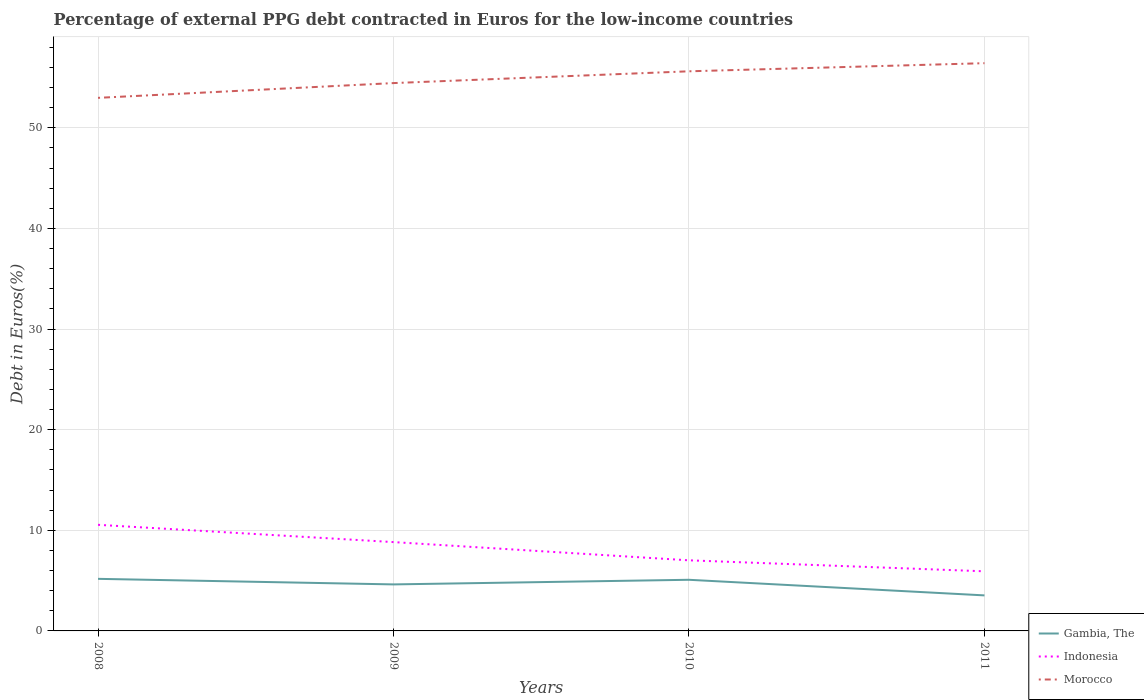How many different coloured lines are there?
Provide a succinct answer. 3. Does the line corresponding to Morocco intersect with the line corresponding to Indonesia?
Offer a very short reply. No. Across all years, what is the maximum percentage of external PPG debt contracted in Euros in Morocco?
Your response must be concise. 52.98. What is the total percentage of external PPG debt contracted in Euros in Gambia, The in the graph?
Your response must be concise. 1.55. What is the difference between the highest and the second highest percentage of external PPG debt contracted in Euros in Morocco?
Offer a very short reply. 3.45. What is the difference between the highest and the lowest percentage of external PPG debt contracted in Euros in Gambia, The?
Offer a terse response. 3. Is the percentage of external PPG debt contracted in Euros in Indonesia strictly greater than the percentage of external PPG debt contracted in Euros in Morocco over the years?
Ensure brevity in your answer.  Yes. How many lines are there?
Ensure brevity in your answer.  3. How many years are there in the graph?
Offer a terse response. 4. What is the difference between two consecutive major ticks on the Y-axis?
Make the answer very short. 10. Does the graph contain any zero values?
Make the answer very short. No. Does the graph contain grids?
Make the answer very short. Yes. Where does the legend appear in the graph?
Ensure brevity in your answer.  Bottom right. What is the title of the graph?
Provide a short and direct response. Percentage of external PPG debt contracted in Euros for the low-income countries. Does "Congo (Democratic)" appear as one of the legend labels in the graph?
Your answer should be very brief. No. What is the label or title of the Y-axis?
Your response must be concise. Debt in Euros(%). What is the Debt in Euros(%) in Gambia, The in 2008?
Offer a terse response. 5.18. What is the Debt in Euros(%) of Indonesia in 2008?
Offer a terse response. 10.55. What is the Debt in Euros(%) of Morocco in 2008?
Your answer should be compact. 52.98. What is the Debt in Euros(%) of Gambia, The in 2009?
Provide a succinct answer. 4.62. What is the Debt in Euros(%) of Indonesia in 2009?
Keep it short and to the point. 8.83. What is the Debt in Euros(%) in Morocco in 2009?
Give a very brief answer. 54.45. What is the Debt in Euros(%) in Gambia, The in 2010?
Offer a terse response. 5.08. What is the Debt in Euros(%) of Indonesia in 2010?
Make the answer very short. 7.02. What is the Debt in Euros(%) in Morocco in 2010?
Your response must be concise. 55.62. What is the Debt in Euros(%) of Gambia, The in 2011?
Your response must be concise. 3.53. What is the Debt in Euros(%) of Indonesia in 2011?
Your answer should be very brief. 5.92. What is the Debt in Euros(%) of Morocco in 2011?
Your response must be concise. 56.43. Across all years, what is the maximum Debt in Euros(%) of Gambia, The?
Offer a very short reply. 5.18. Across all years, what is the maximum Debt in Euros(%) in Indonesia?
Offer a very short reply. 10.55. Across all years, what is the maximum Debt in Euros(%) of Morocco?
Your answer should be very brief. 56.43. Across all years, what is the minimum Debt in Euros(%) of Gambia, The?
Your response must be concise. 3.53. Across all years, what is the minimum Debt in Euros(%) in Indonesia?
Provide a succinct answer. 5.92. Across all years, what is the minimum Debt in Euros(%) in Morocco?
Your response must be concise. 52.98. What is the total Debt in Euros(%) of Gambia, The in the graph?
Make the answer very short. 18.41. What is the total Debt in Euros(%) in Indonesia in the graph?
Your answer should be compact. 32.32. What is the total Debt in Euros(%) of Morocco in the graph?
Offer a very short reply. 219.49. What is the difference between the Debt in Euros(%) in Gambia, The in 2008 and that in 2009?
Give a very brief answer. 0.55. What is the difference between the Debt in Euros(%) in Indonesia in 2008 and that in 2009?
Your answer should be very brief. 1.72. What is the difference between the Debt in Euros(%) of Morocco in 2008 and that in 2009?
Provide a succinct answer. -1.47. What is the difference between the Debt in Euros(%) in Gambia, The in 2008 and that in 2010?
Keep it short and to the point. 0.09. What is the difference between the Debt in Euros(%) in Indonesia in 2008 and that in 2010?
Make the answer very short. 3.53. What is the difference between the Debt in Euros(%) of Morocco in 2008 and that in 2010?
Provide a succinct answer. -2.64. What is the difference between the Debt in Euros(%) of Gambia, The in 2008 and that in 2011?
Offer a terse response. 1.64. What is the difference between the Debt in Euros(%) of Indonesia in 2008 and that in 2011?
Ensure brevity in your answer.  4.62. What is the difference between the Debt in Euros(%) of Morocco in 2008 and that in 2011?
Your response must be concise. -3.45. What is the difference between the Debt in Euros(%) in Gambia, The in 2009 and that in 2010?
Give a very brief answer. -0.46. What is the difference between the Debt in Euros(%) of Indonesia in 2009 and that in 2010?
Offer a terse response. 1.81. What is the difference between the Debt in Euros(%) of Morocco in 2009 and that in 2010?
Your response must be concise. -1.17. What is the difference between the Debt in Euros(%) in Gambia, The in 2009 and that in 2011?
Your answer should be very brief. 1.09. What is the difference between the Debt in Euros(%) in Indonesia in 2009 and that in 2011?
Provide a short and direct response. 2.9. What is the difference between the Debt in Euros(%) in Morocco in 2009 and that in 2011?
Keep it short and to the point. -1.98. What is the difference between the Debt in Euros(%) of Gambia, The in 2010 and that in 2011?
Offer a terse response. 1.55. What is the difference between the Debt in Euros(%) of Indonesia in 2010 and that in 2011?
Your response must be concise. 1.09. What is the difference between the Debt in Euros(%) of Morocco in 2010 and that in 2011?
Ensure brevity in your answer.  -0.81. What is the difference between the Debt in Euros(%) in Gambia, The in 2008 and the Debt in Euros(%) in Indonesia in 2009?
Provide a short and direct response. -3.65. What is the difference between the Debt in Euros(%) in Gambia, The in 2008 and the Debt in Euros(%) in Morocco in 2009?
Keep it short and to the point. -49.28. What is the difference between the Debt in Euros(%) in Indonesia in 2008 and the Debt in Euros(%) in Morocco in 2009?
Provide a succinct answer. -43.91. What is the difference between the Debt in Euros(%) in Gambia, The in 2008 and the Debt in Euros(%) in Indonesia in 2010?
Your answer should be compact. -1.84. What is the difference between the Debt in Euros(%) in Gambia, The in 2008 and the Debt in Euros(%) in Morocco in 2010?
Your answer should be compact. -50.45. What is the difference between the Debt in Euros(%) in Indonesia in 2008 and the Debt in Euros(%) in Morocco in 2010?
Offer a very short reply. -45.08. What is the difference between the Debt in Euros(%) in Gambia, The in 2008 and the Debt in Euros(%) in Indonesia in 2011?
Make the answer very short. -0.75. What is the difference between the Debt in Euros(%) in Gambia, The in 2008 and the Debt in Euros(%) in Morocco in 2011?
Your answer should be very brief. -51.25. What is the difference between the Debt in Euros(%) in Indonesia in 2008 and the Debt in Euros(%) in Morocco in 2011?
Your answer should be compact. -45.88. What is the difference between the Debt in Euros(%) in Gambia, The in 2009 and the Debt in Euros(%) in Indonesia in 2010?
Provide a succinct answer. -2.39. What is the difference between the Debt in Euros(%) in Gambia, The in 2009 and the Debt in Euros(%) in Morocco in 2010?
Offer a terse response. -51. What is the difference between the Debt in Euros(%) of Indonesia in 2009 and the Debt in Euros(%) of Morocco in 2010?
Give a very brief answer. -46.79. What is the difference between the Debt in Euros(%) of Gambia, The in 2009 and the Debt in Euros(%) of Indonesia in 2011?
Give a very brief answer. -1.3. What is the difference between the Debt in Euros(%) of Gambia, The in 2009 and the Debt in Euros(%) of Morocco in 2011?
Provide a succinct answer. -51.81. What is the difference between the Debt in Euros(%) of Indonesia in 2009 and the Debt in Euros(%) of Morocco in 2011?
Offer a very short reply. -47.6. What is the difference between the Debt in Euros(%) of Gambia, The in 2010 and the Debt in Euros(%) of Indonesia in 2011?
Keep it short and to the point. -0.84. What is the difference between the Debt in Euros(%) in Gambia, The in 2010 and the Debt in Euros(%) in Morocco in 2011?
Provide a succinct answer. -51.35. What is the difference between the Debt in Euros(%) in Indonesia in 2010 and the Debt in Euros(%) in Morocco in 2011?
Provide a succinct answer. -49.41. What is the average Debt in Euros(%) of Gambia, The per year?
Your response must be concise. 4.6. What is the average Debt in Euros(%) of Indonesia per year?
Offer a very short reply. 8.08. What is the average Debt in Euros(%) of Morocco per year?
Your answer should be compact. 54.87. In the year 2008, what is the difference between the Debt in Euros(%) in Gambia, The and Debt in Euros(%) in Indonesia?
Give a very brief answer. -5.37. In the year 2008, what is the difference between the Debt in Euros(%) in Gambia, The and Debt in Euros(%) in Morocco?
Your answer should be compact. -47.81. In the year 2008, what is the difference between the Debt in Euros(%) in Indonesia and Debt in Euros(%) in Morocco?
Ensure brevity in your answer.  -42.44. In the year 2009, what is the difference between the Debt in Euros(%) in Gambia, The and Debt in Euros(%) in Indonesia?
Offer a terse response. -4.21. In the year 2009, what is the difference between the Debt in Euros(%) in Gambia, The and Debt in Euros(%) in Morocco?
Your answer should be compact. -49.83. In the year 2009, what is the difference between the Debt in Euros(%) of Indonesia and Debt in Euros(%) of Morocco?
Provide a succinct answer. -45.62. In the year 2010, what is the difference between the Debt in Euros(%) of Gambia, The and Debt in Euros(%) of Indonesia?
Provide a short and direct response. -1.93. In the year 2010, what is the difference between the Debt in Euros(%) of Gambia, The and Debt in Euros(%) of Morocco?
Offer a very short reply. -50.54. In the year 2010, what is the difference between the Debt in Euros(%) of Indonesia and Debt in Euros(%) of Morocco?
Ensure brevity in your answer.  -48.61. In the year 2011, what is the difference between the Debt in Euros(%) of Gambia, The and Debt in Euros(%) of Indonesia?
Give a very brief answer. -2.39. In the year 2011, what is the difference between the Debt in Euros(%) of Gambia, The and Debt in Euros(%) of Morocco?
Make the answer very short. -52.9. In the year 2011, what is the difference between the Debt in Euros(%) of Indonesia and Debt in Euros(%) of Morocco?
Make the answer very short. -50.5. What is the ratio of the Debt in Euros(%) in Gambia, The in 2008 to that in 2009?
Give a very brief answer. 1.12. What is the ratio of the Debt in Euros(%) of Indonesia in 2008 to that in 2009?
Give a very brief answer. 1.19. What is the ratio of the Debt in Euros(%) of Gambia, The in 2008 to that in 2010?
Give a very brief answer. 1.02. What is the ratio of the Debt in Euros(%) of Indonesia in 2008 to that in 2010?
Offer a terse response. 1.5. What is the ratio of the Debt in Euros(%) in Morocco in 2008 to that in 2010?
Ensure brevity in your answer.  0.95. What is the ratio of the Debt in Euros(%) in Gambia, The in 2008 to that in 2011?
Provide a succinct answer. 1.47. What is the ratio of the Debt in Euros(%) in Indonesia in 2008 to that in 2011?
Your response must be concise. 1.78. What is the ratio of the Debt in Euros(%) in Morocco in 2008 to that in 2011?
Your response must be concise. 0.94. What is the ratio of the Debt in Euros(%) in Gambia, The in 2009 to that in 2010?
Provide a succinct answer. 0.91. What is the ratio of the Debt in Euros(%) in Indonesia in 2009 to that in 2010?
Your response must be concise. 1.26. What is the ratio of the Debt in Euros(%) in Morocco in 2009 to that in 2010?
Make the answer very short. 0.98. What is the ratio of the Debt in Euros(%) of Gambia, The in 2009 to that in 2011?
Offer a very short reply. 1.31. What is the ratio of the Debt in Euros(%) of Indonesia in 2009 to that in 2011?
Offer a very short reply. 1.49. What is the ratio of the Debt in Euros(%) in Morocco in 2009 to that in 2011?
Make the answer very short. 0.96. What is the ratio of the Debt in Euros(%) of Gambia, The in 2010 to that in 2011?
Provide a succinct answer. 1.44. What is the ratio of the Debt in Euros(%) of Indonesia in 2010 to that in 2011?
Offer a terse response. 1.18. What is the ratio of the Debt in Euros(%) of Morocco in 2010 to that in 2011?
Keep it short and to the point. 0.99. What is the difference between the highest and the second highest Debt in Euros(%) of Gambia, The?
Your answer should be compact. 0.09. What is the difference between the highest and the second highest Debt in Euros(%) of Indonesia?
Offer a very short reply. 1.72. What is the difference between the highest and the second highest Debt in Euros(%) in Morocco?
Ensure brevity in your answer.  0.81. What is the difference between the highest and the lowest Debt in Euros(%) of Gambia, The?
Offer a very short reply. 1.64. What is the difference between the highest and the lowest Debt in Euros(%) in Indonesia?
Offer a very short reply. 4.62. What is the difference between the highest and the lowest Debt in Euros(%) in Morocco?
Ensure brevity in your answer.  3.45. 